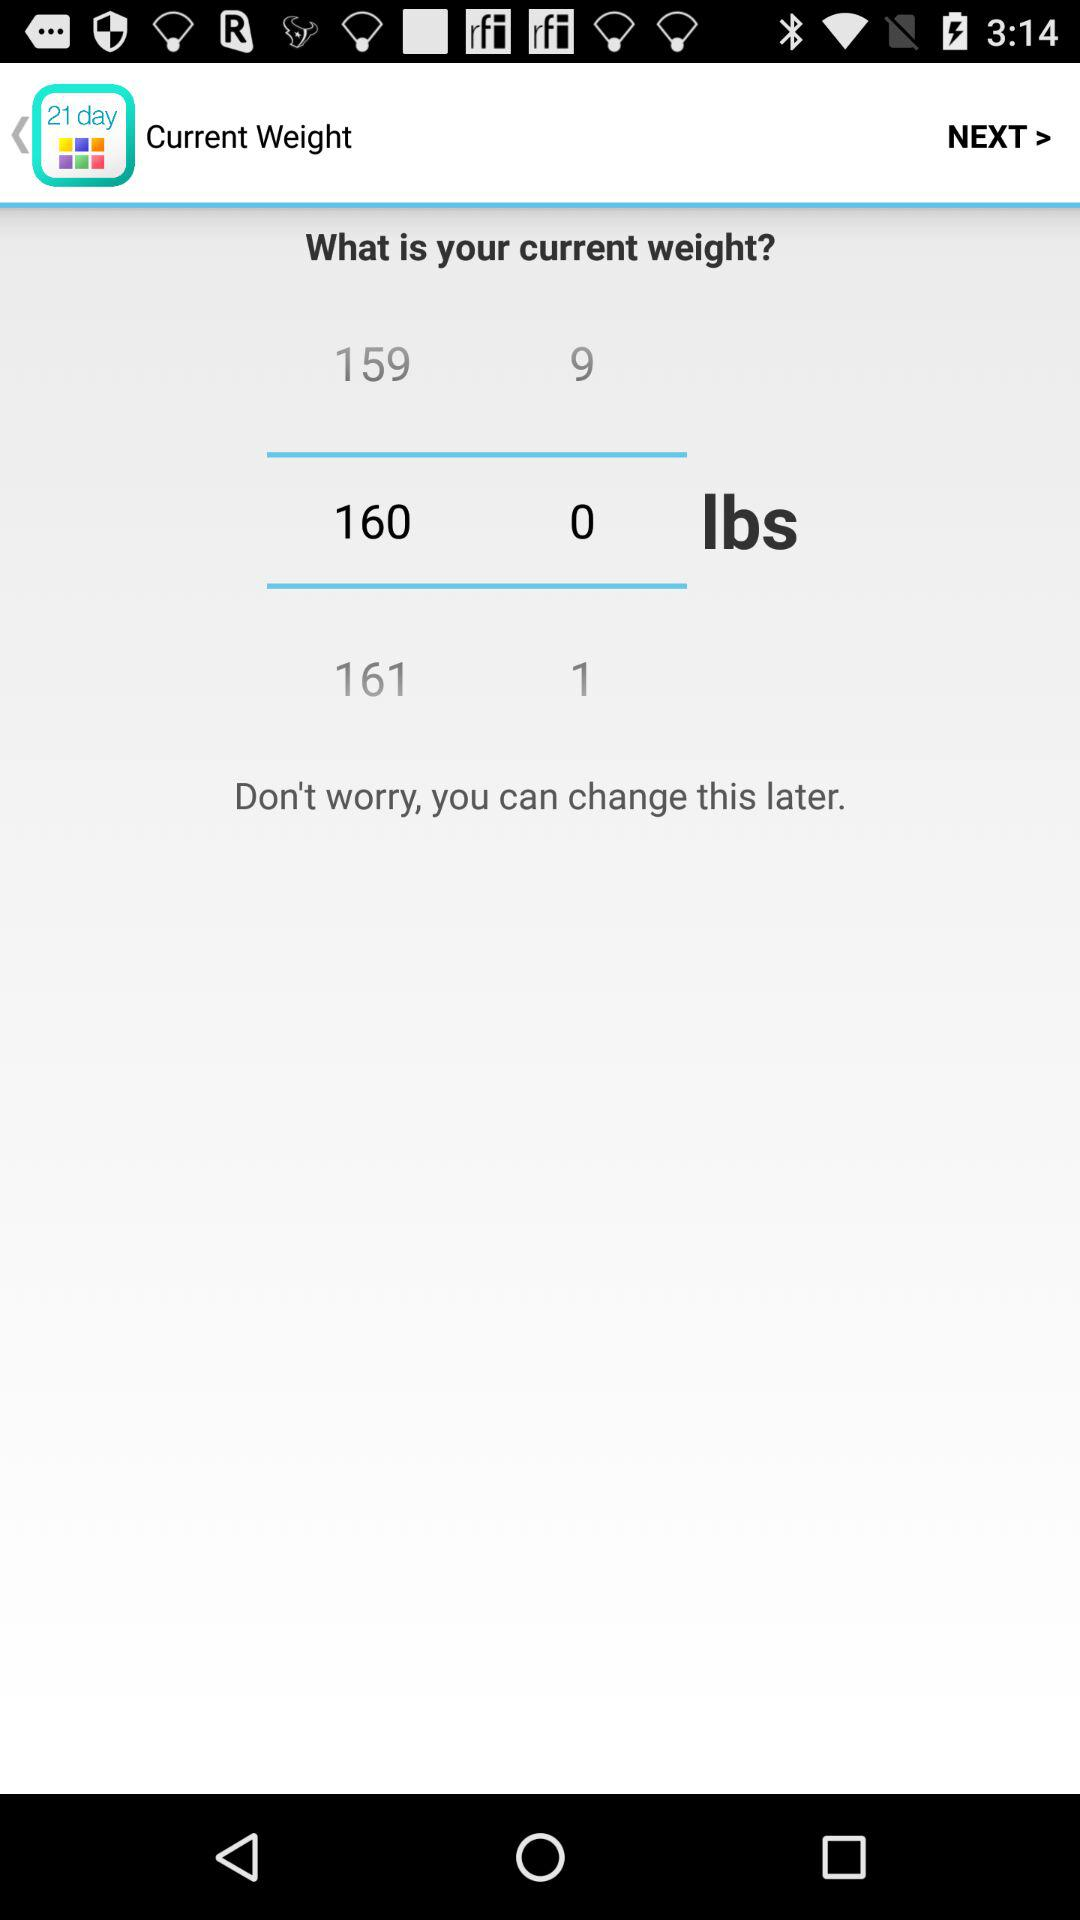What is the unit of weight? The unit of weight is lbs. 